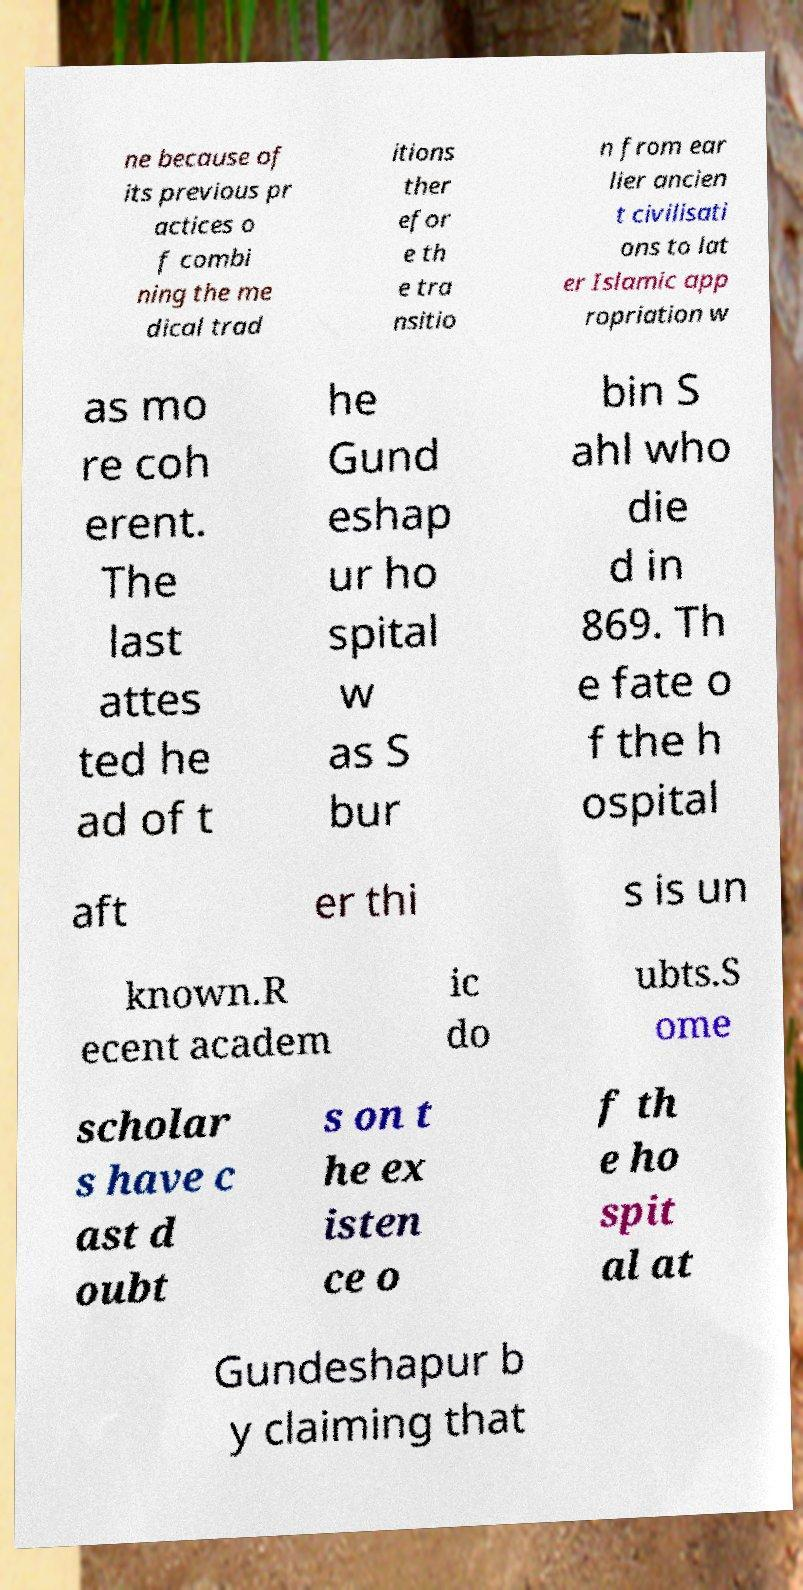Could you extract and type out the text from this image? ne because of its previous pr actices o f combi ning the me dical trad itions ther efor e th e tra nsitio n from ear lier ancien t civilisati ons to lat er Islamic app ropriation w as mo re coh erent. The last attes ted he ad of t he Gund eshap ur ho spital w as S bur bin S ahl who die d in 869. Th e fate o f the h ospital aft er thi s is un known.R ecent academ ic do ubts.S ome scholar s have c ast d oubt s on t he ex isten ce o f th e ho spit al at Gundeshapur b y claiming that 